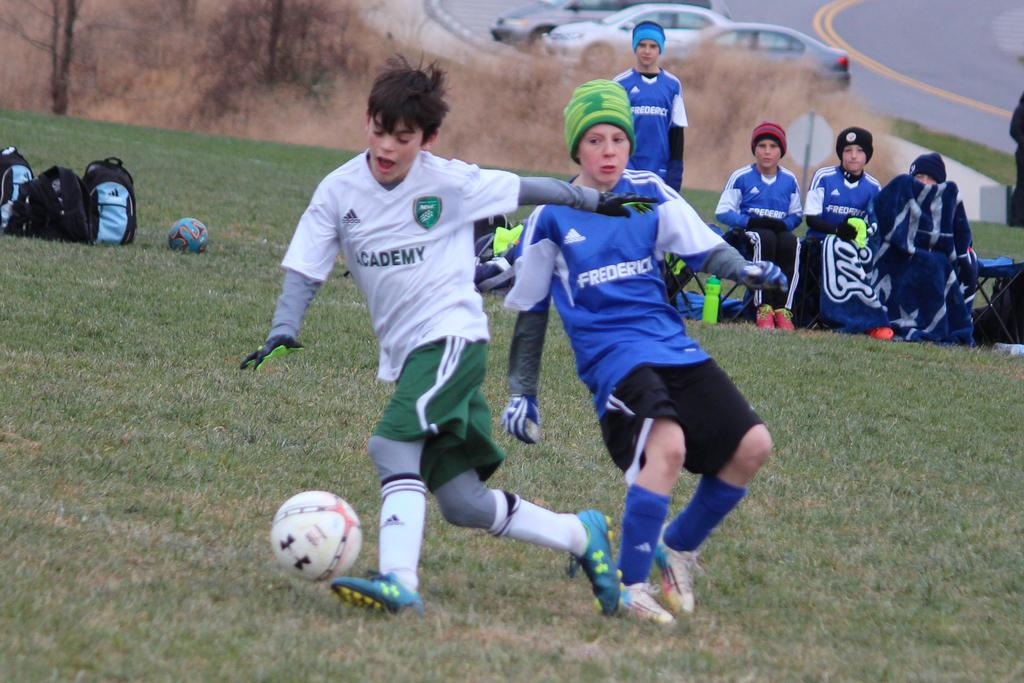<image>
Write a terse but informative summary of the picture. A boy wearing white "academy" soccer jersey runs with the ball past another boy in green. 